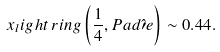Convert formula to latex. <formula><loc_0><loc_0><loc_500><loc_500>x _ { l } i g h t \, r i n g \left ( \frac { 1 } { 4 } , P a d \hat { \prime } e \right ) \sim 0 . 4 4 .</formula> 